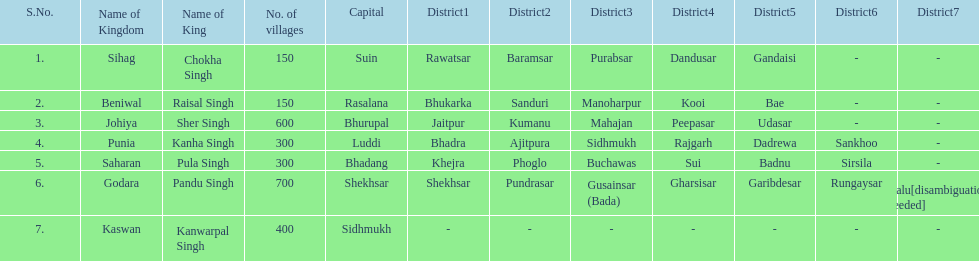How many kingdoms are listed? 7. 